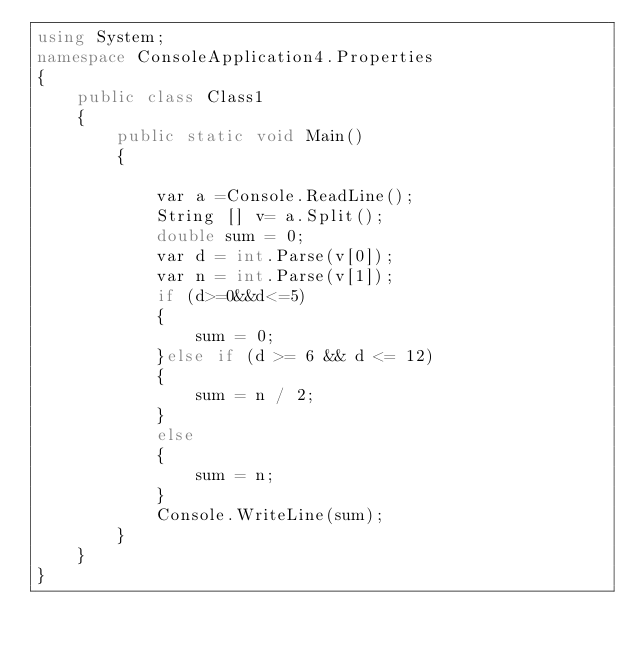Convert code to text. <code><loc_0><loc_0><loc_500><loc_500><_C#_>using System;
namespace ConsoleApplication4.Properties
{
    public class Class1
    {
        public static void Main()
        {
            
            var a =Console.ReadLine();
            String [] v= a.Split();
            double sum = 0;
            var d = int.Parse(v[0]);
            var n = int.Parse(v[1]);
            if (d>=0&&d<=5)
            {
                sum = 0;
            }else if (d >= 6 && d <= 12)
            {
                sum = n / 2;
            }
            else
            {
                sum = n;
            }
            Console.WriteLine(sum);
        }
    }
}
</code> 